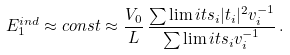Convert formula to latex. <formula><loc_0><loc_0><loc_500><loc_500>E ^ { i n d } _ { 1 } \approx c o n s t \approx \frac { V _ { 0 } } { L } \, \frac { \sum \lim i t s _ { i } | t _ { i } | ^ { 2 } v _ { i } ^ { - 1 } } { \sum \lim i t s _ { i } v _ { i } ^ { - 1 } } \, .</formula> 